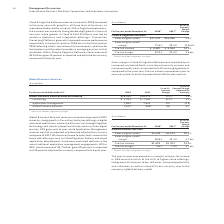According to International Business Machines's financial document, What was the Pre-tax income in 2018? According to the financial document, $1,629 (in millions). The relevant text states: "Pre-tax income $1,629 $1,303 25.0%..." Also, What drove the margins and pre-tax income in GBS improvement? were the result of the shift to higher-value offerings, realignment of resources to key skill areas, increased productivity and utilization as well as a benefit from currency, due to the company’s global delivery model.. The document states: "improvements in margins and pre-tax income in GBS were the result of the shift to higher-value offerings, realignment of resources to key skill areas,..." Also, What was the gross profit margin in 2018? According to the financial document, 26.8%. The relevant text states: "External gross profit margin 26.8% 25.1% 1.7 pts...." Also, can you calculate: What is the increase / (decrease) in the external gross profit from 2017 to 2018? Based on the calculation: 4,448 - 4,033, the result is 415 (in millions). This is based on the information: "External gross profit $4,448 $4,033 10.3% External gross profit $4,448 $4,033 10.3%..." The key data points involved are: 4,033, 4,448. Also, can you calculate: What is the average Pre-tax income? To answer this question, I need to perform calculations using the financial data. The calculation is: (1,629 + 1,303) / 2, which equals 1466 (in millions). This is based on the information: "Pre-tax income $1,629 $1,303 25.0% Pre-tax income $1,629 $1,303 25.0%..." The key data points involved are: 1,303, 1,629. Also, can you calculate: What is the increase / (decrease) in the Pre-tax margin from 2017 to 2018? Based on the calculation: 9.6% - 7.9%, the result is 1.7 (percentage). This is based on the information: "Pre-tax margin 9.6% 7.9% 1.7 pts. Pre-tax margin 9.6% 7.9% 1.7 pts...." The key data points involved are: 7.9, 9.6. 